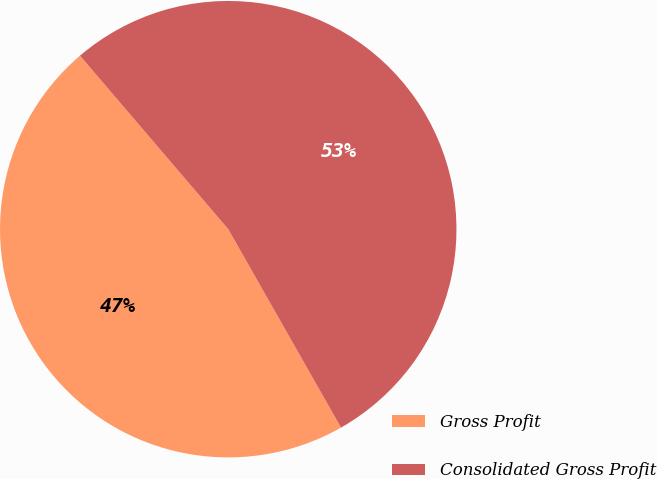Convert chart. <chart><loc_0><loc_0><loc_500><loc_500><pie_chart><fcel>Gross Profit<fcel>Consolidated Gross Profit<nl><fcel>46.97%<fcel>53.03%<nl></chart> 